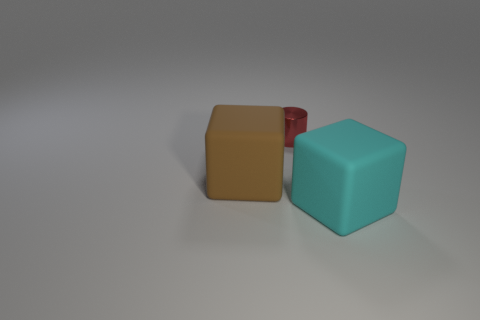How many blue objects are either blocks or rubber cylinders?
Make the answer very short. 0. Do the large brown block and the small cylinder have the same material?
Offer a terse response. No. What number of cyan rubber cubes are behind the large object in front of the big brown matte block?
Give a very brief answer. 0. Do the brown thing and the cyan block have the same size?
Give a very brief answer. Yes. What number of blocks have the same material as the brown object?
Make the answer very short. 1. What is the size of the other rubber thing that is the same shape as the cyan thing?
Offer a terse response. Large. There is a matte object in front of the large brown rubber thing; does it have the same shape as the brown thing?
Provide a short and direct response. Yes. There is a big matte object that is in front of the large thing to the left of the red shiny cylinder; what is its shape?
Your answer should be very brief. Cube. Are there any other things that are the same shape as the cyan rubber thing?
Your response must be concise. Yes. The other rubber object that is the same shape as the brown thing is what color?
Give a very brief answer. Cyan. 